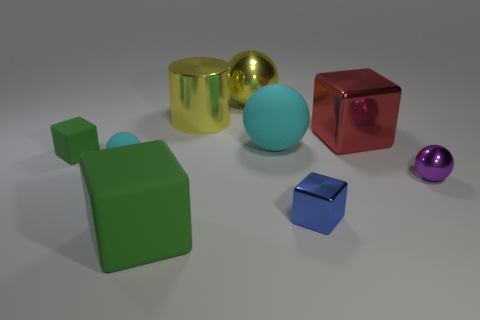There is a purple thing that is made of the same material as the large yellow sphere; what shape is it?
Your answer should be very brief. Sphere. Are there any other things that are the same material as the large yellow ball?
Make the answer very short. Yes. How many big objects are either matte spheres or yellow metal cylinders?
Provide a short and direct response. 2. The thing that is the same color as the large shiny sphere is what shape?
Your answer should be very brief. Cylinder. Does the cyan object that is left of the big cyan matte ball have the same material as the blue cube?
Offer a terse response. No. The big sphere that is behind the cyan rubber thing on the right side of the large yellow cylinder is made of what material?
Provide a succinct answer. Metal. What number of other large objects have the same shape as the purple thing?
Your response must be concise. 2. There is a green rubber block that is left of the large cube that is in front of the cyan rubber object to the left of the big cyan ball; what is its size?
Your answer should be compact. Small. What number of cyan things are either big balls or large matte objects?
Offer a very short reply. 1. There is a purple object on the right side of the big red shiny cube; is it the same shape as the large cyan rubber thing?
Offer a terse response. Yes. 